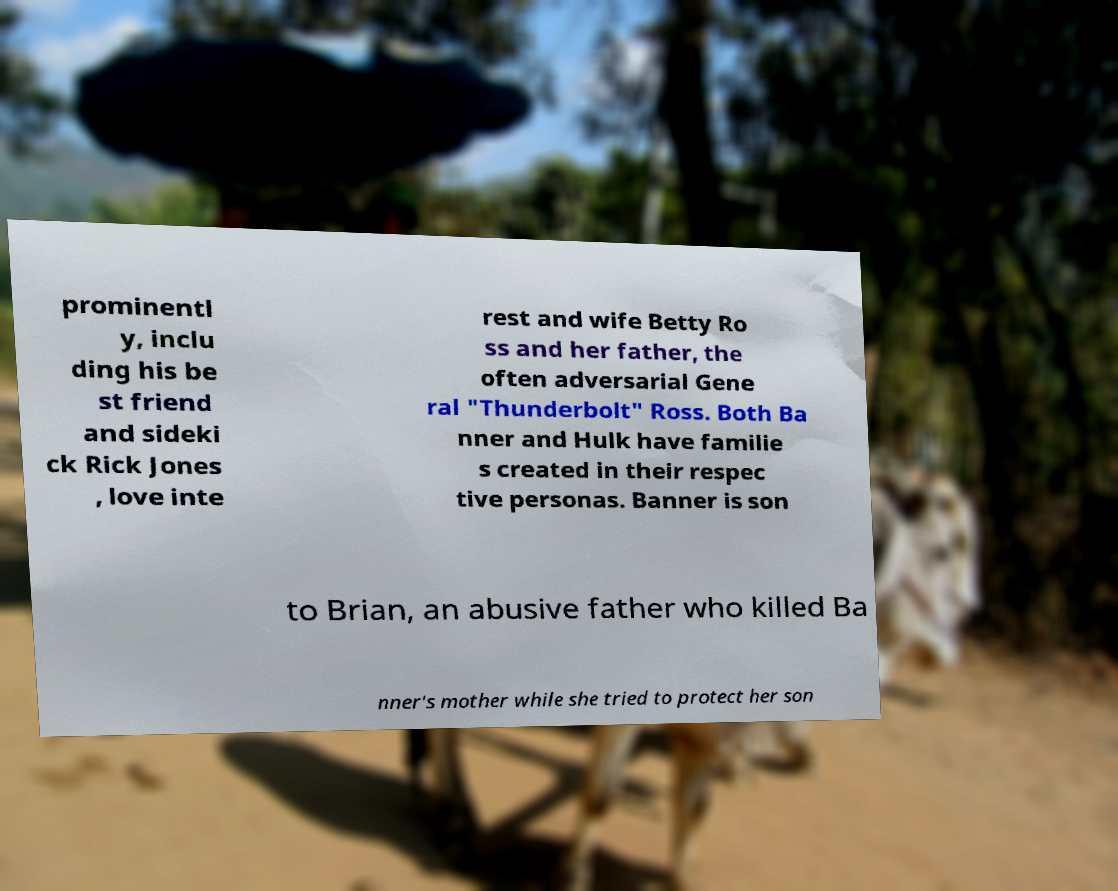There's text embedded in this image that I need extracted. Can you transcribe it verbatim? prominentl y, inclu ding his be st friend and sideki ck Rick Jones , love inte rest and wife Betty Ro ss and her father, the often adversarial Gene ral "Thunderbolt" Ross. Both Ba nner and Hulk have familie s created in their respec tive personas. Banner is son to Brian, an abusive father who killed Ba nner's mother while she tried to protect her son 